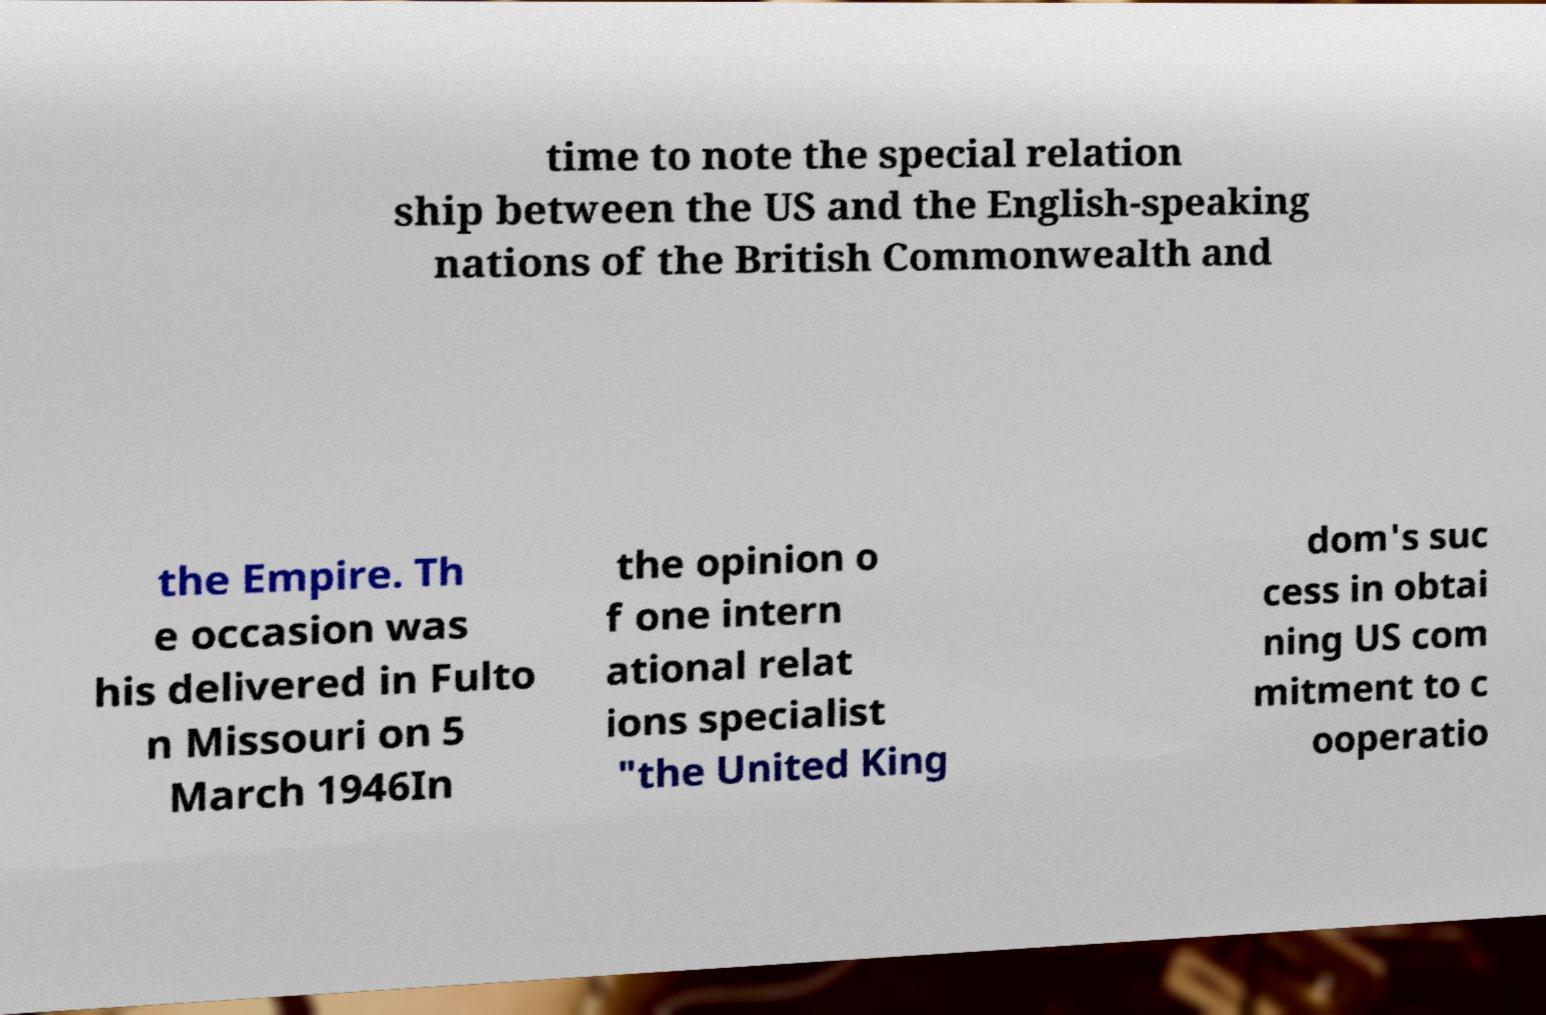I need the written content from this picture converted into text. Can you do that? time to note the special relation ship between the US and the English-speaking nations of the British Commonwealth and the Empire. Th e occasion was his delivered in Fulto n Missouri on 5 March 1946In the opinion o f one intern ational relat ions specialist "the United King dom's suc cess in obtai ning US com mitment to c ooperatio 